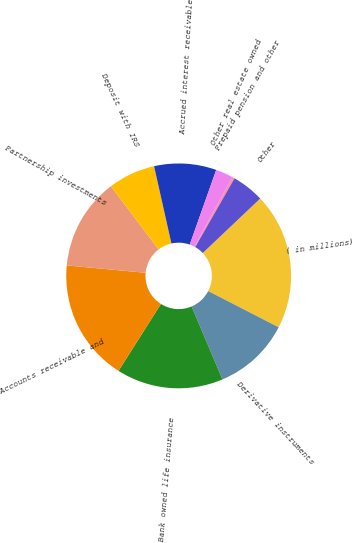Convert chart to OTSL. <chart><loc_0><loc_0><loc_500><loc_500><pie_chart><fcel>( in millions)<fcel>Derivative instruments<fcel>Bank owned life insurance<fcel>Accounts receivable and<fcel>Partnership investments<fcel>Deposit with IRS<fcel>Accrued interest receivable<fcel>Other real estate owned<fcel>Prepaid pension and other<fcel>Other<nl><fcel>19.64%<fcel>11.07%<fcel>15.36%<fcel>17.5%<fcel>13.21%<fcel>6.79%<fcel>8.93%<fcel>2.5%<fcel>0.36%<fcel>4.64%<nl></chart> 